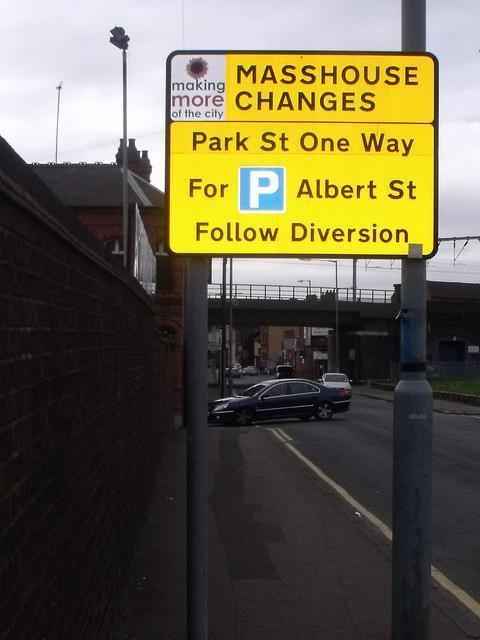Why is the yellow sign posted outdoors?
Make your selection from the four choices given to correctly answer the question.
Options: To scare, to inform, to protest, to sell. To inform. 